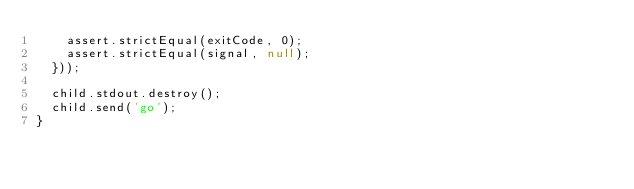Convert code to text. <code><loc_0><loc_0><loc_500><loc_500><_JavaScript_>    assert.strictEqual(exitCode, 0);
    assert.strictEqual(signal, null);
  }));

  child.stdout.destroy();
  child.send('go');
}
</code> 